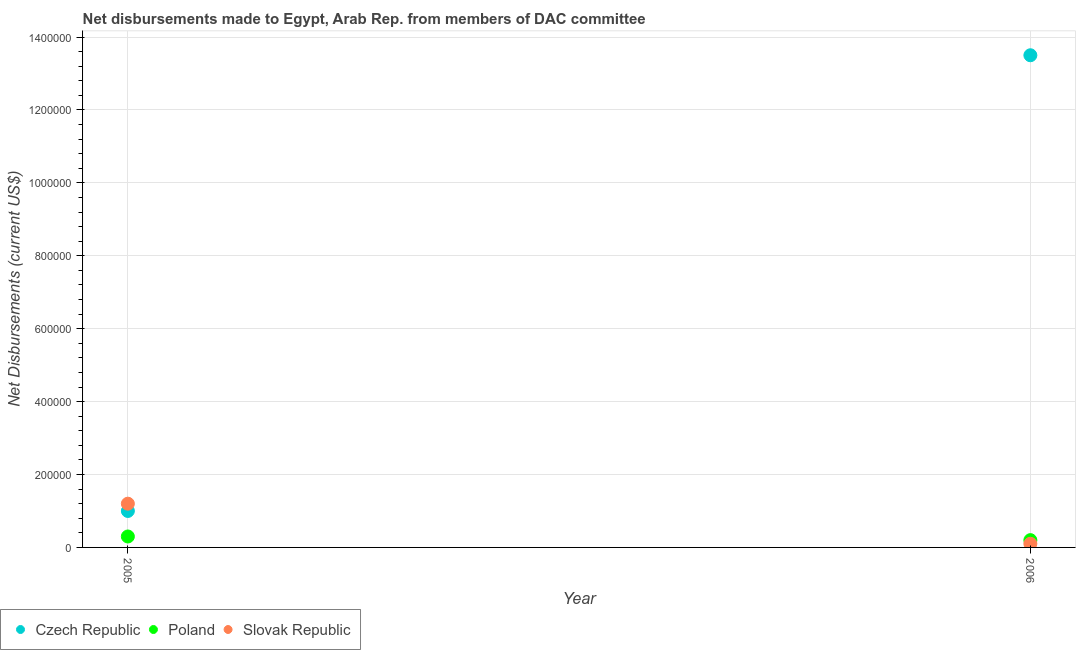What is the net disbursements made by czech republic in 2006?
Provide a succinct answer. 1.35e+06. Across all years, what is the maximum net disbursements made by slovak republic?
Ensure brevity in your answer.  1.20e+05. Across all years, what is the minimum net disbursements made by slovak republic?
Give a very brief answer. 10000. In which year was the net disbursements made by slovak republic maximum?
Your response must be concise. 2005. In which year was the net disbursements made by czech republic minimum?
Provide a succinct answer. 2005. What is the total net disbursements made by slovak republic in the graph?
Provide a succinct answer. 1.30e+05. What is the difference between the net disbursements made by slovak republic in 2005 and that in 2006?
Offer a very short reply. 1.10e+05. What is the difference between the net disbursements made by czech republic in 2006 and the net disbursements made by poland in 2005?
Your answer should be compact. 1.32e+06. What is the average net disbursements made by poland per year?
Ensure brevity in your answer.  2.50e+04. In the year 2006, what is the difference between the net disbursements made by czech republic and net disbursements made by poland?
Give a very brief answer. 1.33e+06. In how many years, is the net disbursements made by slovak republic greater than 720000 US$?
Ensure brevity in your answer.  0. What is the ratio of the net disbursements made by slovak republic in 2005 to that in 2006?
Your answer should be very brief. 12. Is the net disbursements made by slovak republic in 2005 less than that in 2006?
Make the answer very short. No. Does the net disbursements made by poland monotonically increase over the years?
Ensure brevity in your answer.  No. Is the net disbursements made by slovak republic strictly greater than the net disbursements made by poland over the years?
Provide a succinct answer. No. Is the net disbursements made by czech republic strictly less than the net disbursements made by slovak republic over the years?
Your answer should be compact. No. How many years are there in the graph?
Provide a succinct answer. 2. Does the graph contain grids?
Provide a succinct answer. Yes. How are the legend labels stacked?
Provide a succinct answer. Horizontal. What is the title of the graph?
Give a very brief answer. Net disbursements made to Egypt, Arab Rep. from members of DAC committee. Does "Textiles and clothing" appear as one of the legend labels in the graph?
Give a very brief answer. No. What is the label or title of the Y-axis?
Keep it short and to the point. Net Disbursements (current US$). What is the Net Disbursements (current US$) of Slovak Republic in 2005?
Provide a succinct answer. 1.20e+05. What is the Net Disbursements (current US$) of Czech Republic in 2006?
Provide a short and direct response. 1.35e+06. What is the Net Disbursements (current US$) in Poland in 2006?
Make the answer very short. 2.00e+04. Across all years, what is the maximum Net Disbursements (current US$) of Czech Republic?
Provide a short and direct response. 1.35e+06. Across all years, what is the minimum Net Disbursements (current US$) of Poland?
Offer a terse response. 2.00e+04. Across all years, what is the minimum Net Disbursements (current US$) of Slovak Republic?
Give a very brief answer. 10000. What is the total Net Disbursements (current US$) of Czech Republic in the graph?
Your response must be concise. 1.45e+06. What is the difference between the Net Disbursements (current US$) in Czech Republic in 2005 and that in 2006?
Provide a short and direct response. -1.25e+06. What is the difference between the Net Disbursements (current US$) in Poland in 2005 and that in 2006?
Your response must be concise. 10000. What is the average Net Disbursements (current US$) in Czech Republic per year?
Ensure brevity in your answer.  7.25e+05. What is the average Net Disbursements (current US$) of Poland per year?
Ensure brevity in your answer.  2.50e+04. What is the average Net Disbursements (current US$) of Slovak Republic per year?
Provide a short and direct response. 6.50e+04. In the year 2005, what is the difference between the Net Disbursements (current US$) of Czech Republic and Net Disbursements (current US$) of Poland?
Keep it short and to the point. 7.00e+04. In the year 2005, what is the difference between the Net Disbursements (current US$) in Czech Republic and Net Disbursements (current US$) in Slovak Republic?
Give a very brief answer. -2.00e+04. In the year 2006, what is the difference between the Net Disbursements (current US$) in Czech Republic and Net Disbursements (current US$) in Poland?
Ensure brevity in your answer.  1.33e+06. In the year 2006, what is the difference between the Net Disbursements (current US$) of Czech Republic and Net Disbursements (current US$) of Slovak Republic?
Make the answer very short. 1.34e+06. What is the ratio of the Net Disbursements (current US$) of Czech Republic in 2005 to that in 2006?
Give a very brief answer. 0.07. What is the difference between the highest and the second highest Net Disbursements (current US$) of Czech Republic?
Your answer should be very brief. 1.25e+06. What is the difference between the highest and the lowest Net Disbursements (current US$) of Czech Republic?
Provide a short and direct response. 1.25e+06. 